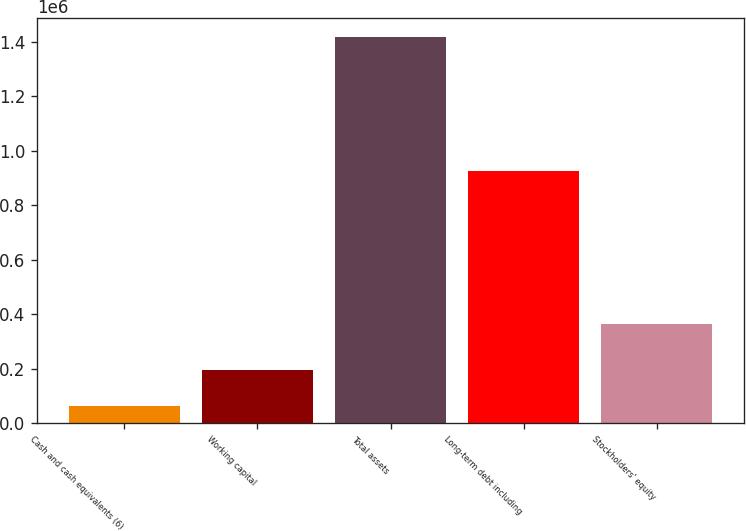Convert chart. <chart><loc_0><loc_0><loc_500><loc_500><bar_chart><fcel>Cash and cash equivalents (6)<fcel>Working capital<fcel>Total assets<fcel>Long-term debt including<fcel>Stockholders' equity<nl><fcel>61217<fcel>196766<fcel>1.41671e+06<fcel>925000<fcel>363041<nl></chart> 